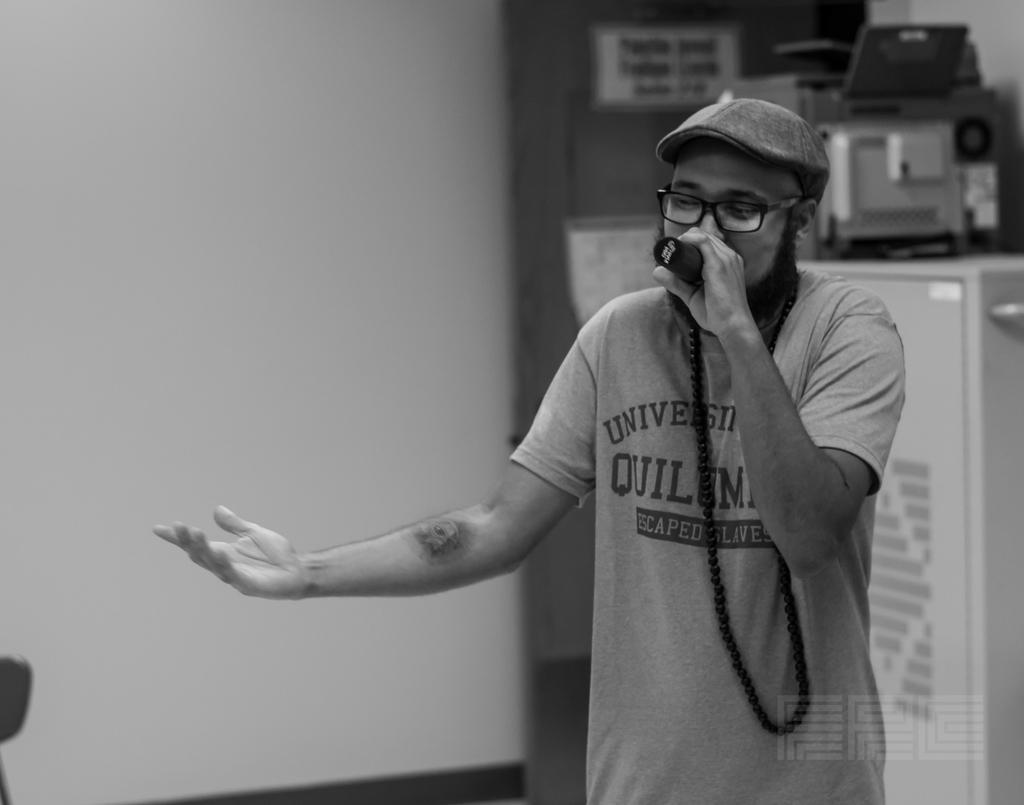Can you describe this image briefly? In this image person is singing by holding the mike. At the back side there are few objects. 